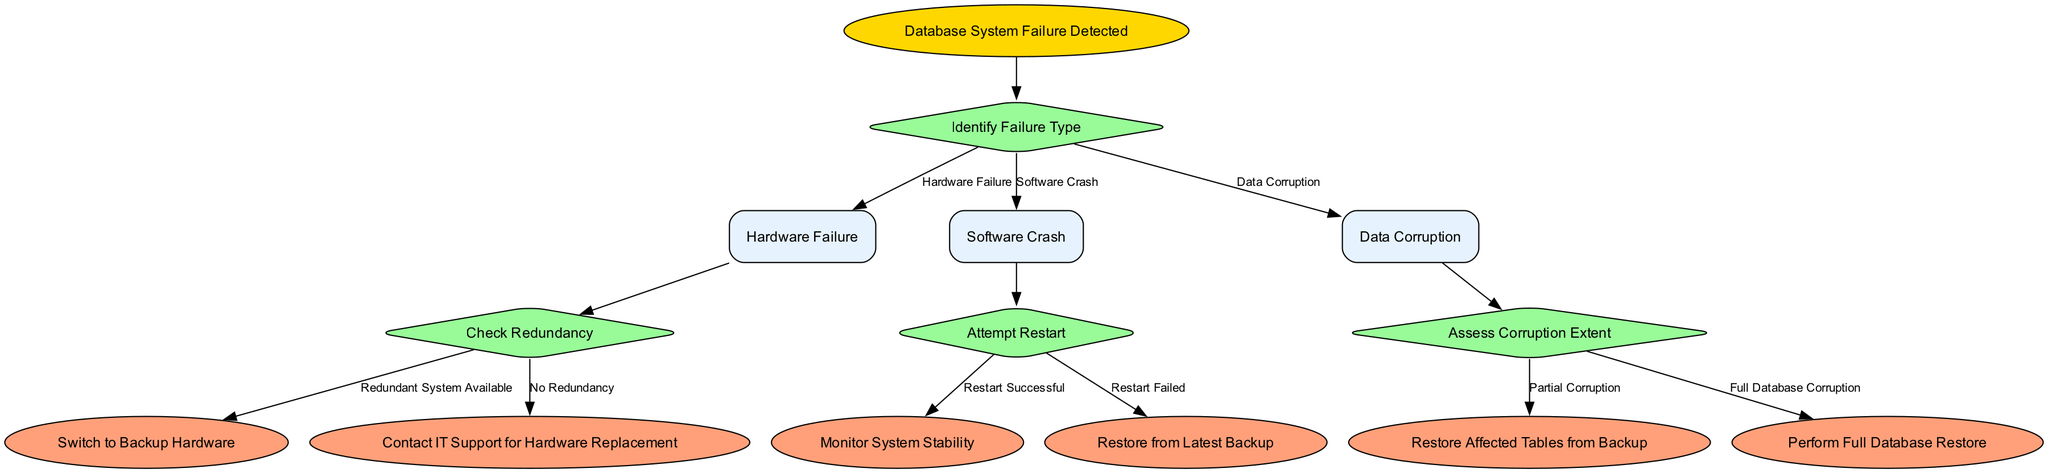What is the root of the decision tree? The root node of the decision tree represents the initial state of the decision-making process, which is "Database System Failure Detected."
Answer: Database System Failure Detected How many main decision types are there? The diagram contains three main decision types under "Identify Failure Type," which are "Hardware Failure," "Software Crash," and "Data Corruption."
Answer: Three What is the action taken for "Hardware Failure" when there is no redundancy? When "No Redundancy" is selected for "Hardware Failure," the action specified is to "Contact IT Support for Hardware Replacement."
Answer: Contact IT Support for Hardware Replacement What happens after a "Software Crash" if the restart is successful? If the restart is successful after a "Software Crash," the next step is to "Monitor System Stability."
Answer: Monitor System Stability What is the next node after "Assess Corruption Extent" when there is partial corruption? In the case of "Partial Corruption," the next action is to "Restore Affected Tables from Backup."
Answer: Restore Affected Tables from Backup Which decision leads to contacting IT support? The decision that leads to contacting IT support is "Hardware Failure" with the option "No Redundancy."
Answer: Hardware Failure with No Redundancy What action is taken after a failed restart of a "Software Crash"? If the restart fails, the action taken is to "Restore from Latest Backup."
Answer: Restore from Latest Backup What are the two options under "Assess Corruption Extent"? The two options listed under "Assess Corruption Extent" are "Partial Corruption" and "Full Database Corruption."
Answer: Partial Corruption and Full Database Corruption 